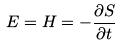Convert formula to latex. <formula><loc_0><loc_0><loc_500><loc_500>E = H = - \frac { \partial S } { \partial t }</formula> 